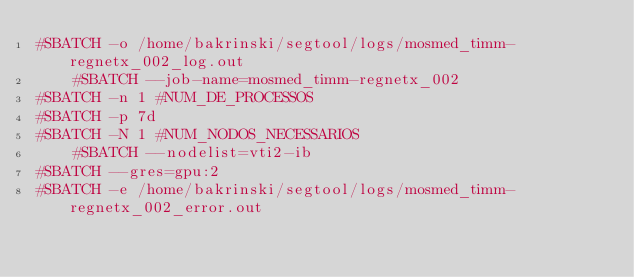<code> <loc_0><loc_0><loc_500><loc_500><_Bash_>#SBATCH -o /home/bakrinski/segtool/logs/mosmed_timm-regnetx_002_log.out
    #SBATCH --job-name=mosmed_timm-regnetx_002
#SBATCH -n 1 #NUM_DE_PROCESSOS
#SBATCH -p 7d
#SBATCH -N 1 #NUM_NODOS_NECESSARIOS
    #SBATCH --nodelist=vti2-ib
#SBATCH --gres=gpu:2
#SBATCH -e /home/bakrinski/segtool/logs/mosmed_timm-regnetx_002_error.out
</code> 